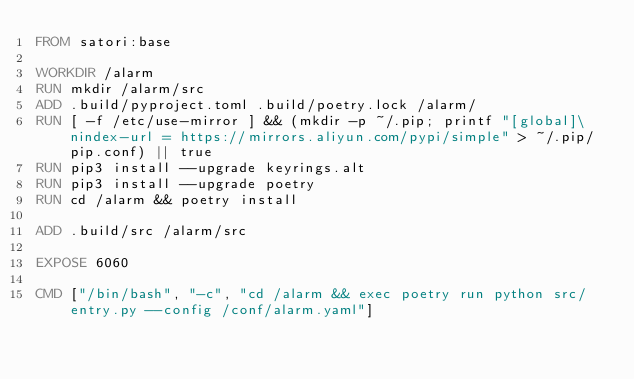<code> <loc_0><loc_0><loc_500><loc_500><_Dockerfile_>FROM satori:base

WORKDIR /alarm
RUN mkdir /alarm/src
ADD .build/pyproject.toml .build/poetry.lock /alarm/
RUN [ -f /etc/use-mirror ] && (mkdir -p ~/.pip; printf "[global]\nindex-url = https://mirrors.aliyun.com/pypi/simple" > ~/.pip/pip.conf) || true
RUN pip3 install --upgrade keyrings.alt
RUN pip3 install --upgrade poetry
RUN cd /alarm && poetry install

ADD .build/src /alarm/src

EXPOSE 6060

CMD ["/bin/bash", "-c", "cd /alarm && exec poetry run python src/entry.py --config /conf/alarm.yaml"]
</code> 